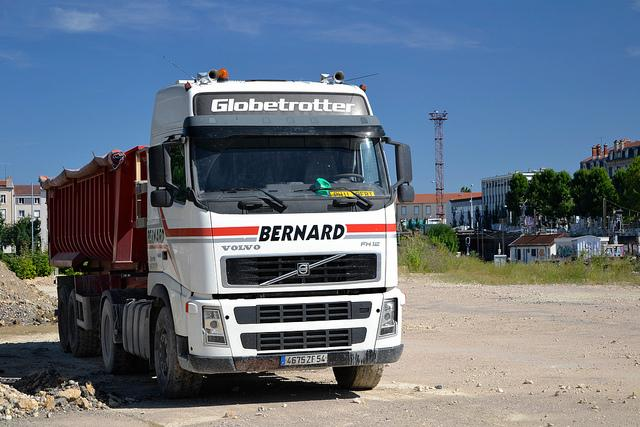This truck shares a name with a popular American Sporting expo group who plays what sport? Please explain your reasoning. basketball. The name on the top of the bus says globetrotters.  for anyone who follows american sports, they know that the harlem globetrotters were the ambassadors of basketball. 